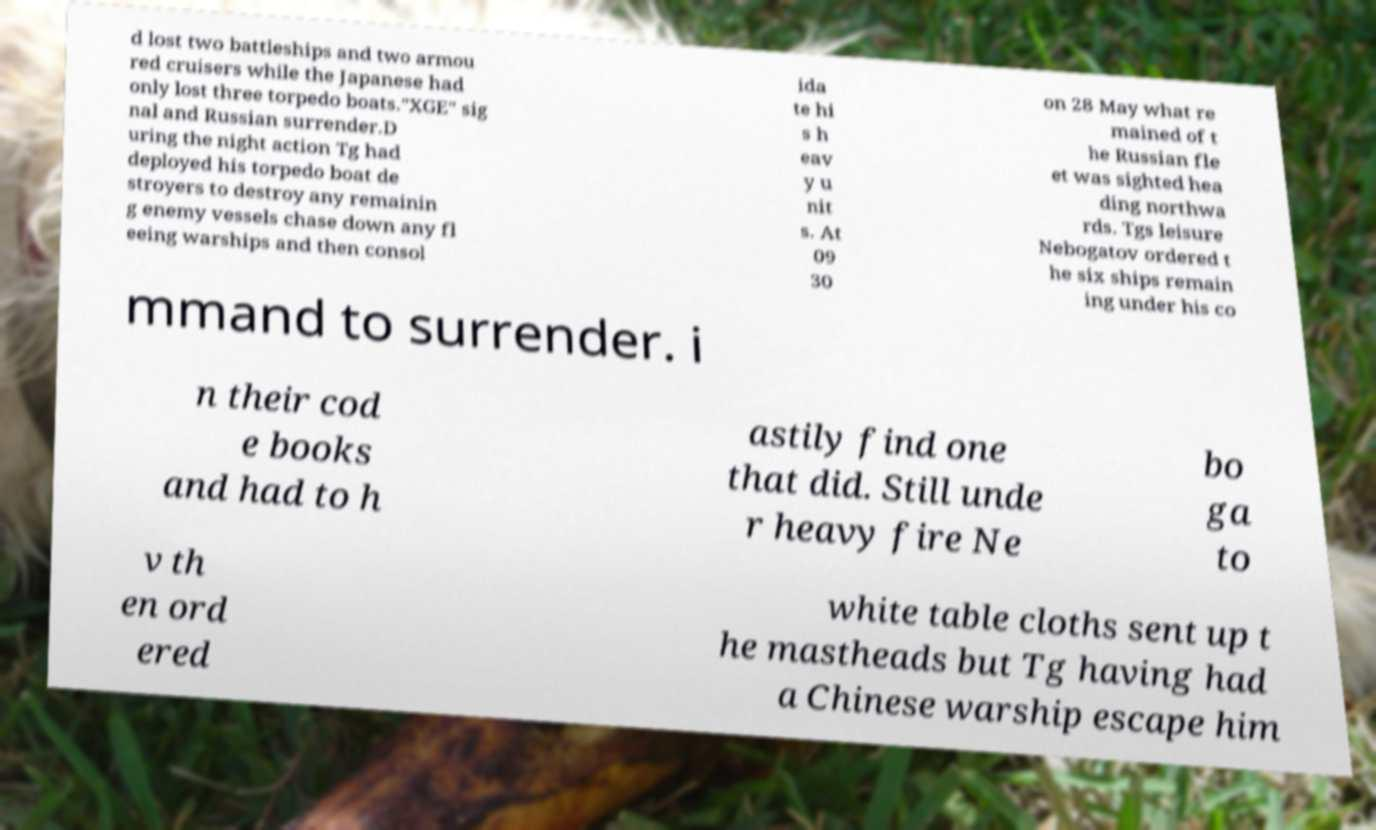Could you assist in decoding the text presented in this image and type it out clearly? d lost two battleships and two armou red cruisers while the Japanese had only lost three torpedo boats."XGE" sig nal and Russian surrender.D uring the night action Tg had deployed his torpedo boat de stroyers to destroy any remainin g enemy vessels chase down any fl eeing warships and then consol ida te hi s h eav y u nit s. At 09 30 on 28 May what re mained of t he Russian fle et was sighted hea ding northwa rds. Tgs leisure Nebogatov ordered t he six ships remain ing under his co mmand to surrender. i n their cod e books and had to h astily find one that did. Still unde r heavy fire Ne bo ga to v th en ord ered white table cloths sent up t he mastheads but Tg having had a Chinese warship escape him 